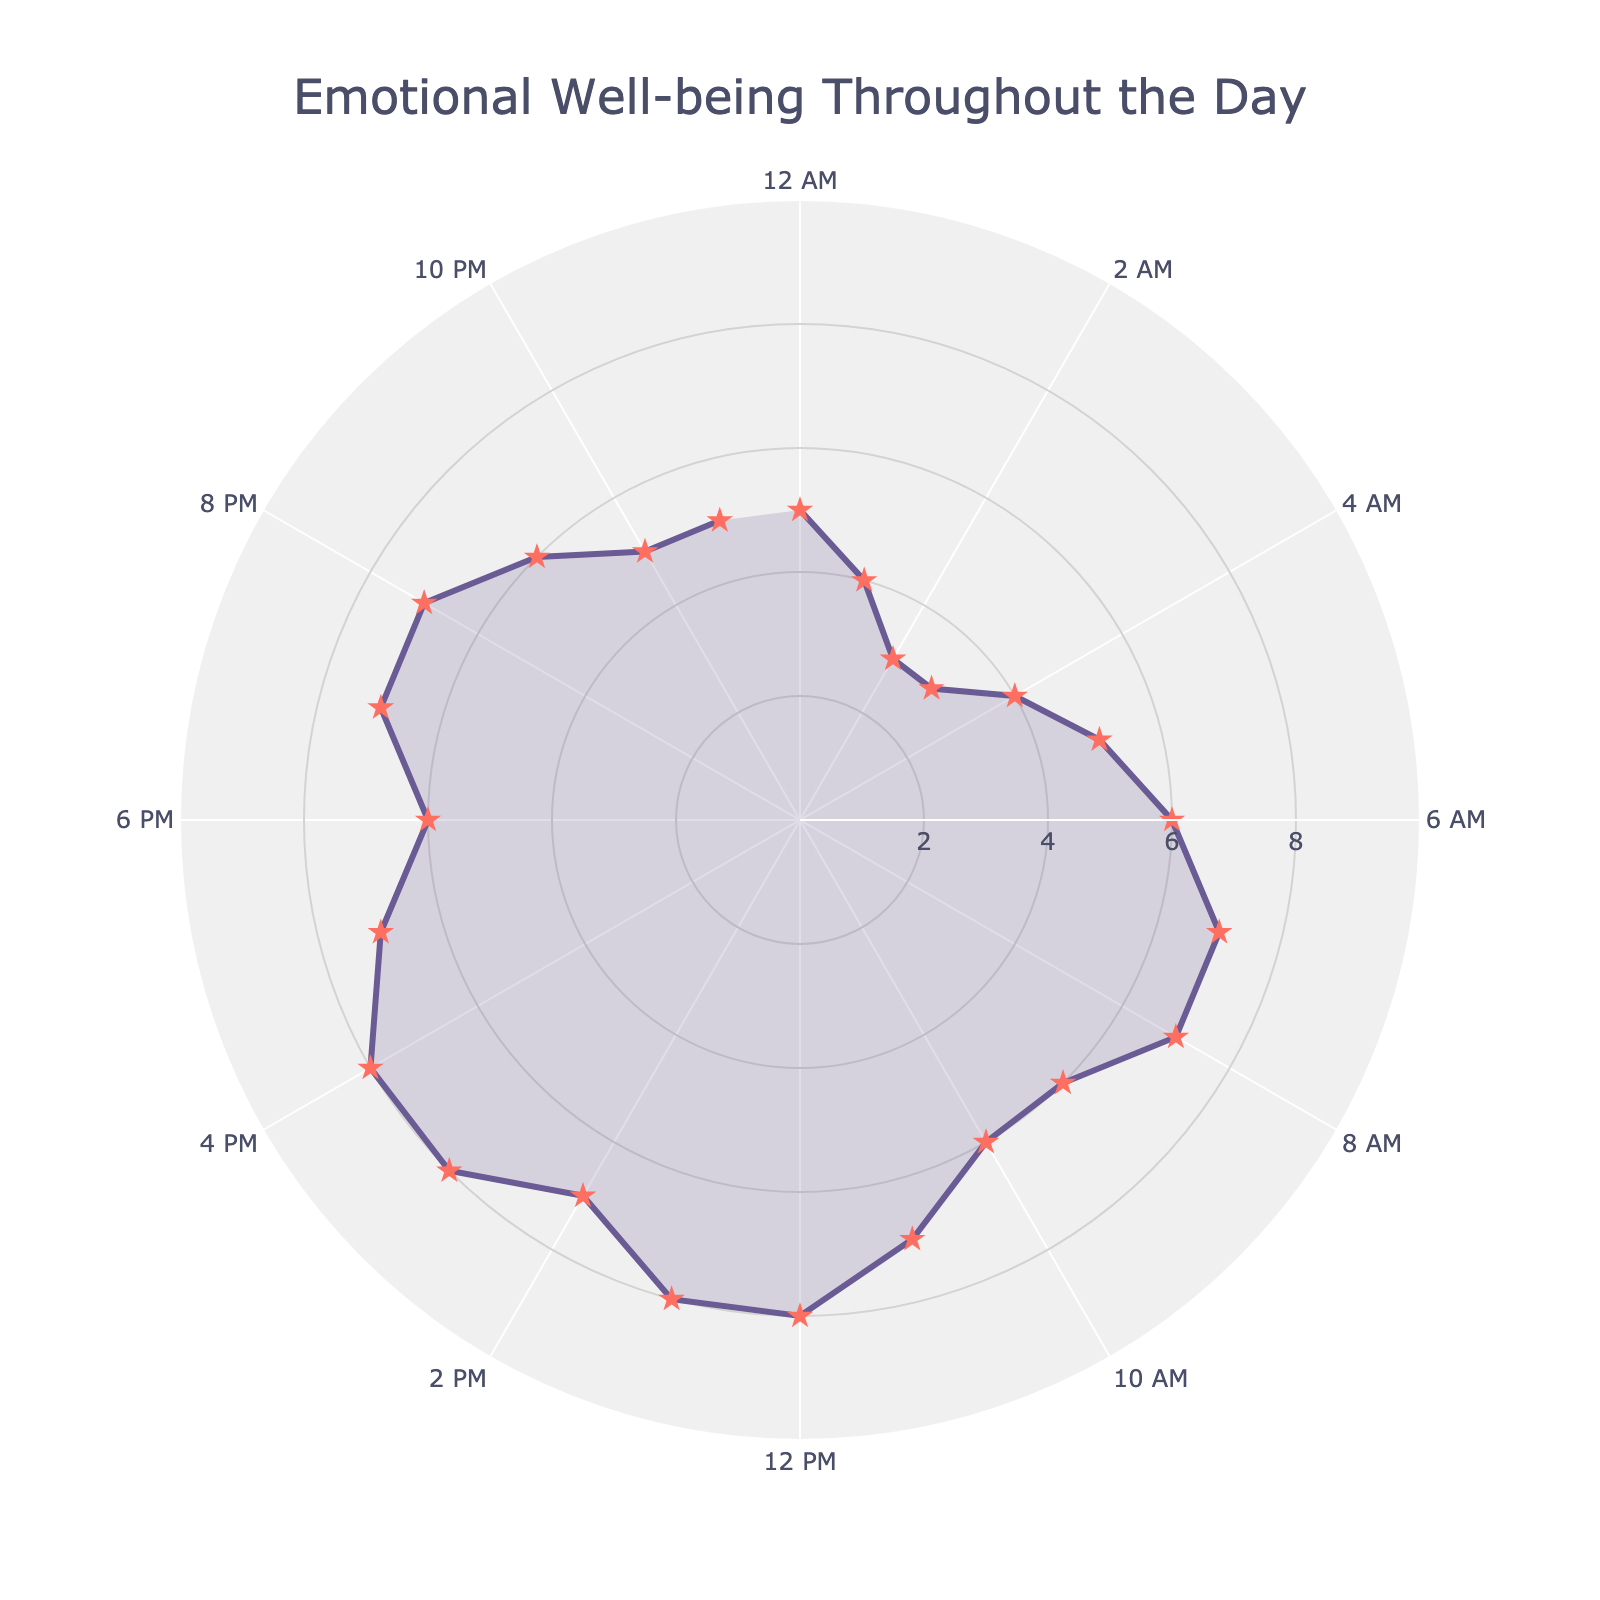What's the title of the chart? The title is written at the top of the polar chart. It provides a summary of what the chart represents.
Answer: Emotional Well-being Throughout the Day How many data points are presented in the chart? To find the number of data points, look at the number of markers or the distinctive segments on the chart representing different times of day. Count them from 12:00 AM to 11:00 PM.
Answer: 24 Which time of day has the highest emotional well-being rating? By observing the peaks in the polar chart, the segments representing the emotional well-being ratings throughout the day, locate the highest peak which corresponds to a rating of 8. Then, check the associated time indications.
Answer: 12:00 PM - 1:00 PM, 1:00 PM - 2:00 PM, 3:00 PM - 4:00 PM, 4:00 PM - 5:00 PM What is the rating at 6:00 AM? Identify the segment of the chart that corresponds to 6:00 AM by locating the label on the axis and read the associated rating.
Answer: 6 What is the average emotional well-being rating for the duration between 1:00 PM and 3:00 PM? The ratings from 1:00 PM to 3:00 PM are 8, 8, and 7. Add these ratings (8 + 8 + 7) and divide by the number of ratings (3) to find the average.
Answer: 7.67 During which time frames does the rating drop to its minimum throughout the day? To find the time frames with the minimum rating, look for the lowest points on the chart which correspond to the morning and late night hours, and check the time labels. The minimum rating observed is 3.
Answer: 2:00 AM - 3:00 AM, 3:00 AM - 4:00 AM Compare the emotional well-being rating at 9:00 AM to that at 9:00 PM. Which one is higher? Locate the data points on the chart for 9:00 AM and 9:00 PM, and compare their ratings.
Answer: 9:00 AM What is the difference between the highest and lowest ratings throughout the day? Identify the highest rating (8) and the lowest rating (3). Subtract the lowest rating from the highest rating (8 - 3) to find the difference.
Answer: 5 At what times of the day do the ratings rise or fall noticeably? Look for steep rises or falls in the polar chart lines between sequential data points and note the corresponding times when these changes occur.
Answer: 3:00 AM - 4:00 AM (rise), 9:00 AM - 12:00 PM (rise), 12:00 PM - 2:00 PM (fall) 